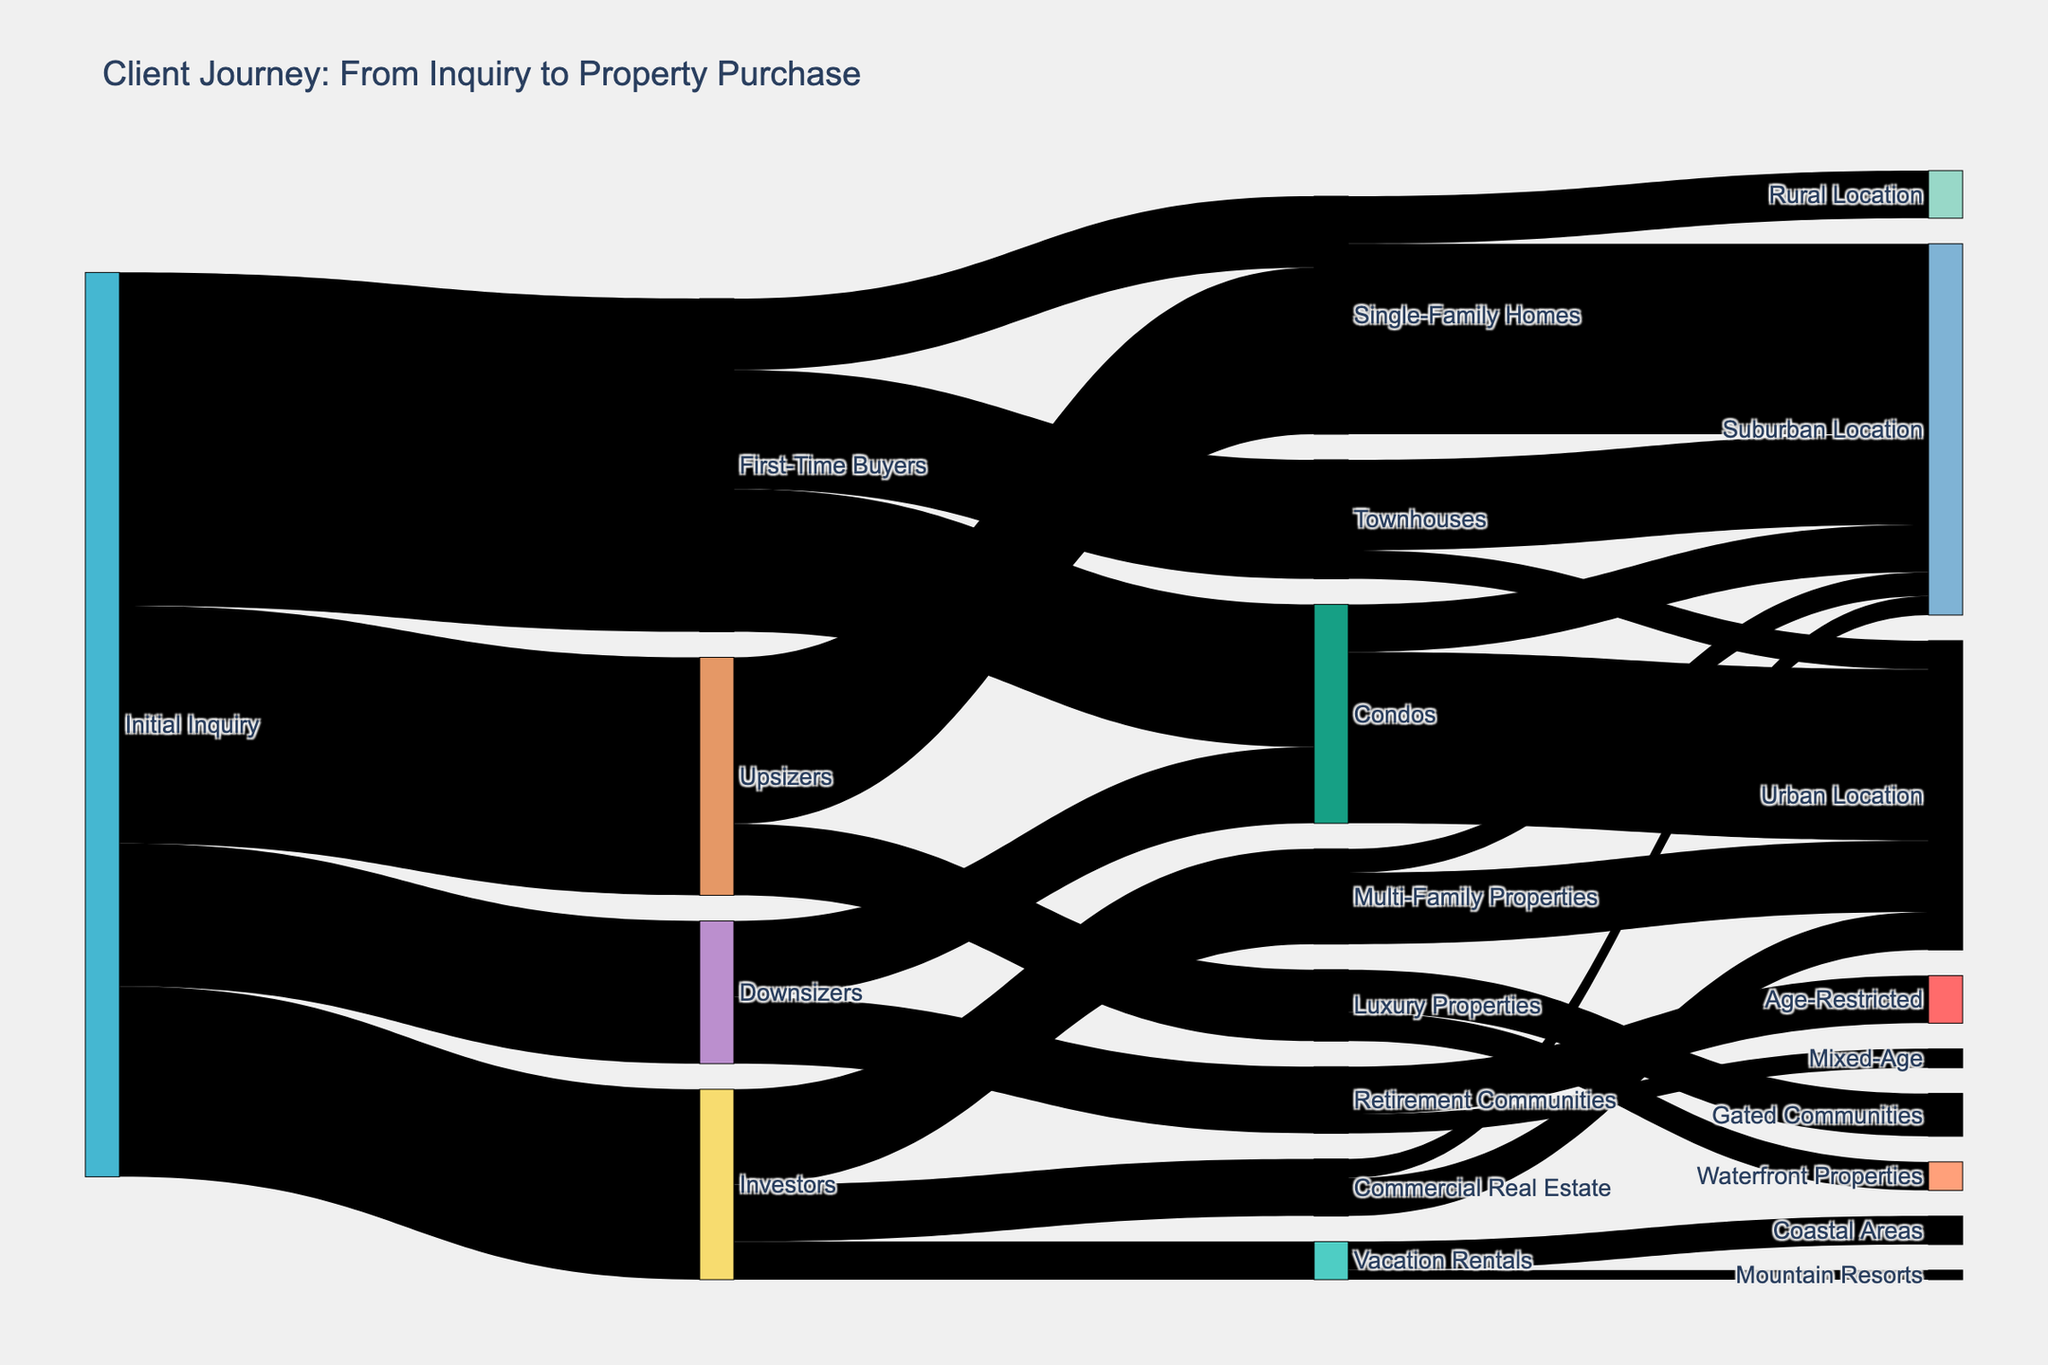what is the title of the Sankey Diagram? The title of the Sankey Diagram is typically located at the top of the figure. Reading it directly from the top, the title is "Client Journey: From Inquiry to Property Purchase".
Answer: Client Journey: From Inquiry to Property Purchase How many client categories are there at the initial inquiry stage? Check the 'Source' nodes with the label 'Initial Inquiry'. You will find four categories: First-Time Buyers, Investors, Upsizers, and Downsizers.
Answer: Four Which client type made the most initial inquiries? Look at the width of the flows originating from 'Initial Inquiry'. The widest flow leads to 'First-Time Buyers' with a value of 350.
Answer: First-Time Buyers How many First-Time Buyers prefer Single-Family Homes? Identify the flow connecting 'First-Time Buyers' to 'Single-Family Homes' and read the value directly from the diagram, which is 75.
Answer: 75 Which type of property is least preferred among Investors? Identify all properties linked to 'Investors' and compare their values. 'Vacation Rentals' has the lowest value of 40.
Answer: Vacation Rentals How many clients preferred suburban locations for Single-Family Homes? Check the flow from 'Single-Family Homes' to 'Suburban Location'. The flow has a value of 200.
Answer: 200 What is the total number of inquiries for Condos, including all client types? Sum the values of all the flows leading to 'Condos'. This includes 150 (First-Time Buyers) and 80 (Downsizers), totaling 150 + 80 = 230.
Answer: 230 How many Luxury Properties inquiries are for Gated Communities compared to Waterfront Properties? Compare the flows from 'Luxury Properties' to 'Gated Communities' (45) and 'Waterfront Properties' (30).
Answer: Gated Communities has 15 more inquiries Which client category has the highest preference for properties in Urban Locations? Sum the value of flows into 'Urban Location' for each client category and compare. For Condos, it's 180 (First-Time Buyers), and for Investors it's [Multi-Family Properties, 75] + [Commercial Real Estate, 40] = 115. 'Condos' receives the highest preference.
Answer: First-Time Buyers via Condos How many more inquiries opted for Retirement Communities over Multi-Family Properties? Sum the value of flows into 'Retirement Communities' (80 + 70 = 150) and compare it with 'Multi-Family Properties' (100). The difference is 150 - 100 = 50.
Answer: 50 